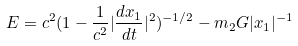<formula> <loc_0><loc_0><loc_500><loc_500>E = c ^ { 2 } ( 1 - \frac { 1 } { c ^ { 2 } } | \frac { d { x } _ { 1 } } { d t } | ^ { 2 } ) ^ { - 1 / 2 } - m _ { 2 } G | { x } _ { 1 } | ^ { - 1 }</formula> 